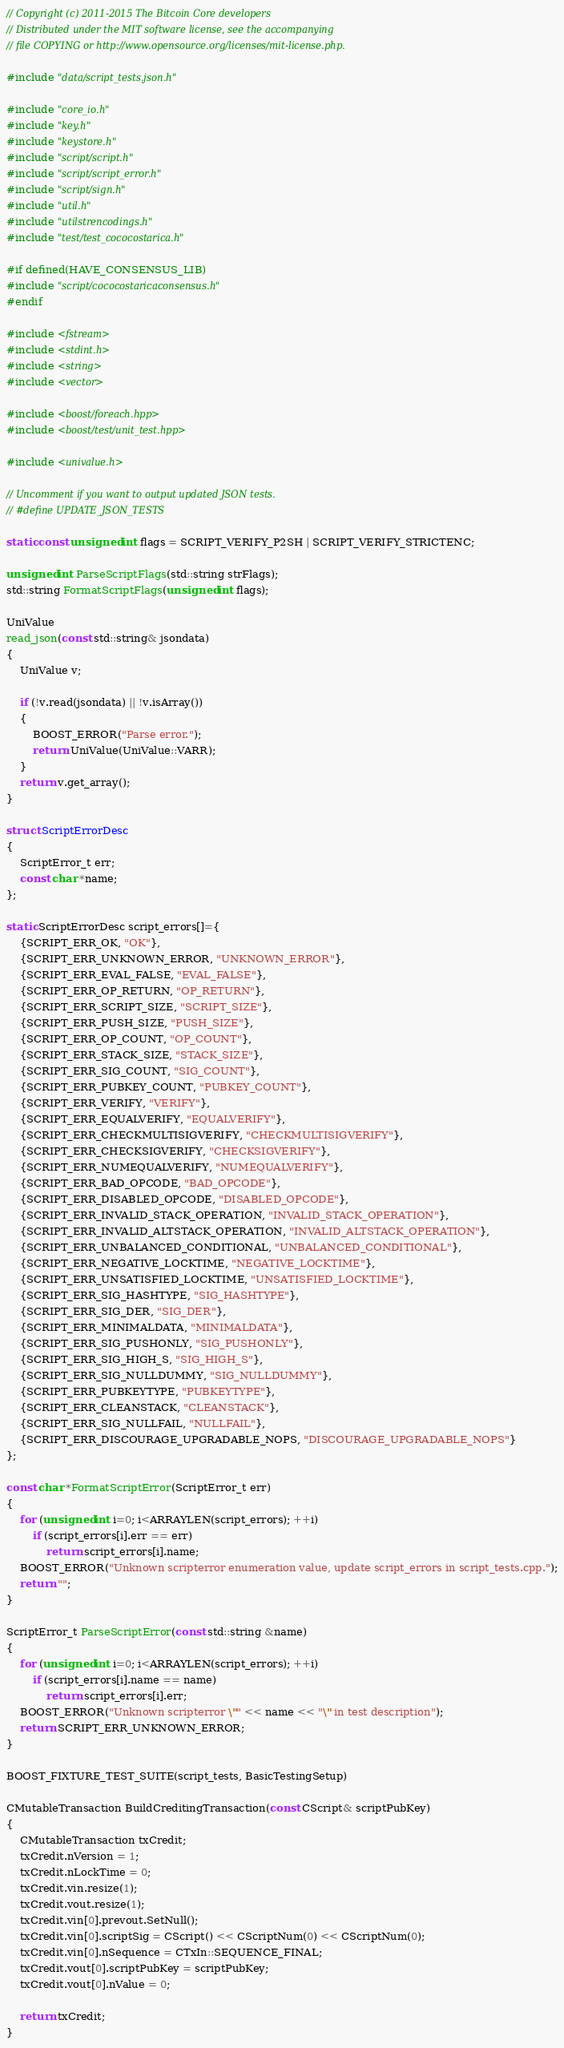Convert code to text. <code><loc_0><loc_0><loc_500><loc_500><_C++_>// Copyright (c) 2011-2015 The Bitcoin Core developers
// Distributed under the MIT software license, see the accompanying
// file COPYING or http://www.opensource.org/licenses/mit-license.php.

#include "data/script_tests.json.h"

#include "core_io.h"
#include "key.h"
#include "keystore.h"
#include "script/script.h"
#include "script/script_error.h"
#include "script/sign.h"
#include "util.h"
#include "utilstrencodings.h"
#include "test/test_cococostarica.h"

#if defined(HAVE_CONSENSUS_LIB)
#include "script/cococostaricaconsensus.h"
#endif

#include <fstream>
#include <stdint.h>
#include <string>
#include <vector>

#include <boost/foreach.hpp>
#include <boost/test/unit_test.hpp>

#include <univalue.h>

// Uncomment if you want to output updated JSON tests.
// #define UPDATE_JSON_TESTS

static const unsigned int flags = SCRIPT_VERIFY_P2SH | SCRIPT_VERIFY_STRICTENC;

unsigned int ParseScriptFlags(std::string strFlags);
std::string FormatScriptFlags(unsigned int flags);

UniValue
read_json(const std::string& jsondata)
{
    UniValue v;

    if (!v.read(jsondata) || !v.isArray())
    {
        BOOST_ERROR("Parse error.");
        return UniValue(UniValue::VARR);
    }
    return v.get_array();
}

struct ScriptErrorDesc
{
    ScriptError_t err;
    const char *name;
};

static ScriptErrorDesc script_errors[]={
    {SCRIPT_ERR_OK, "OK"},
    {SCRIPT_ERR_UNKNOWN_ERROR, "UNKNOWN_ERROR"},
    {SCRIPT_ERR_EVAL_FALSE, "EVAL_FALSE"},
    {SCRIPT_ERR_OP_RETURN, "OP_RETURN"},
    {SCRIPT_ERR_SCRIPT_SIZE, "SCRIPT_SIZE"},
    {SCRIPT_ERR_PUSH_SIZE, "PUSH_SIZE"},
    {SCRIPT_ERR_OP_COUNT, "OP_COUNT"},
    {SCRIPT_ERR_STACK_SIZE, "STACK_SIZE"},
    {SCRIPT_ERR_SIG_COUNT, "SIG_COUNT"},
    {SCRIPT_ERR_PUBKEY_COUNT, "PUBKEY_COUNT"},
    {SCRIPT_ERR_VERIFY, "VERIFY"},
    {SCRIPT_ERR_EQUALVERIFY, "EQUALVERIFY"},
    {SCRIPT_ERR_CHECKMULTISIGVERIFY, "CHECKMULTISIGVERIFY"},
    {SCRIPT_ERR_CHECKSIGVERIFY, "CHECKSIGVERIFY"},
    {SCRIPT_ERR_NUMEQUALVERIFY, "NUMEQUALVERIFY"},
    {SCRIPT_ERR_BAD_OPCODE, "BAD_OPCODE"},
    {SCRIPT_ERR_DISABLED_OPCODE, "DISABLED_OPCODE"},
    {SCRIPT_ERR_INVALID_STACK_OPERATION, "INVALID_STACK_OPERATION"},
    {SCRIPT_ERR_INVALID_ALTSTACK_OPERATION, "INVALID_ALTSTACK_OPERATION"},
    {SCRIPT_ERR_UNBALANCED_CONDITIONAL, "UNBALANCED_CONDITIONAL"},
    {SCRIPT_ERR_NEGATIVE_LOCKTIME, "NEGATIVE_LOCKTIME"},
    {SCRIPT_ERR_UNSATISFIED_LOCKTIME, "UNSATISFIED_LOCKTIME"},
    {SCRIPT_ERR_SIG_HASHTYPE, "SIG_HASHTYPE"},
    {SCRIPT_ERR_SIG_DER, "SIG_DER"},
    {SCRIPT_ERR_MINIMALDATA, "MINIMALDATA"},
    {SCRIPT_ERR_SIG_PUSHONLY, "SIG_PUSHONLY"},
    {SCRIPT_ERR_SIG_HIGH_S, "SIG_HIGH_S"},
    {SCRIPT_ERR_SIG_NULLDUMMY, "SIG_NULLDUMMY"},
    {SCRIPT_ERR_PUBKEYTYPE, "PUBKEYTYPE"},
    {SCRIPT_ERR_CLEANSTACK, "CLEANSTACK"},
    {SCRIPT_ERR_SIG_NULLFAIL, "NULLFAIL"},
    {SCRIPT_ERR_DISCOURAGE_UPGRADABLE_NOPS, "DISCOURAGE_UPGRADABLE_NOPS"}
};

const char *FormatScriptError(ScriptError_t err)
{
    for (unsigned int i=0; i<ARRAYLEN(script_errors); ++i)
        if (script_errors[i].err == err)
            return script_errors[i].name;
    BOOST_ERROR("Unknown scripterror enumeration value, update script_errors in script_tests.cpp.");
    return "";
}

ScriptError_t ParseScriptError(const std::string &name)
{
    for (unsigned int i=0; i<ARRAYLEN(script_errors); ++i)
        if (script_errors[i].name == name)
            return script_errors[i].err;
    BOOST_ERROR("Unknown scripterror \"" << name << "\" in test description");
    return SCRIPT_ERR_UNKNOWN_ERROR;
}

BOOST_FIXTURE_TEST_SUITE(script_tests, BasicTestingSetup)

CMutableTransaction BuildCreditingTransaction(const CScript& scriptPubKey)
{
    CMutableTransaction txCredit;
    txCredit.nVersion = 1;
    txCredit.nLockTime = 0;
    txCredit.vin.resize(1);
    txCredit.vout.resize(1);
    txCredit.vin[0].prevout.SetNull();
    txCredit.vin[0].scriptSig = CScript() << CScriptNum(0) << CScriptNum(0);
    txCredit.vin[0].nSequence = CTxIn::SEQUENCE_FINAL;
    txCredit.vout[0].scriptPubKey = scriptPubKey;
    txCredit.vout[0].nValue = 0;

    return txCredit;
}
</code> 